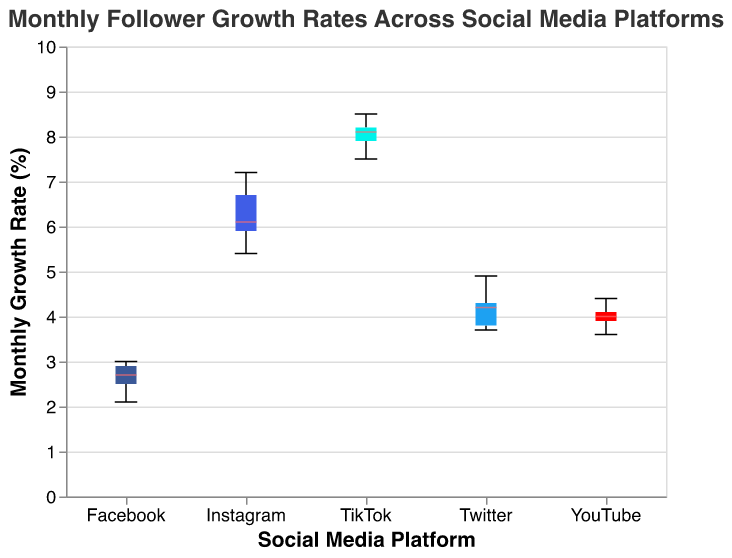How many social media platforms are compared in the plot? The x-axis displays the social media platforms. There are five distinct platforms visible: Instagram, Twitter, Facebook, TikTok, and YouTube.
Answer: 5 Which platform shows the highest median monthly follower growth rate? To find the highest median, look at where the median line is located within each box plot. TikTok has the highest median line, which is visually highest among the platforms.
Answer: TikTok Is the median growth rate for Facebook greater than that for Twitter? Analyze the position of the median lines within their respective boxes for Facebook and Twitter. The median for Facebook is lower than for Twitter.
Answer: No What is the spread of monthly growth rates on TikTok compared to Instagram? To compare the spread, look at the range from the minimum to the maximum values in the notched box plot. TikTok has a wider spread compared to Instagram.
Answer: TikTok has a wider spread Which platform has the narrowest interquartile range? The interquartile range (IQR) is the width of the box in the plot. Facebook has the narrowest interquartile range as its box is the smallest among all the platforms.
Answer: Facebook What is the difference in the median growth rates between Instagram and YouTube? Identify the median lines for Instagram and YouTube. The median for Instagram is around 6.1%, and for YouTube, it is around 4.0%. Subtract YouTube's median from Instagram's median: 6.1% - 4.0% = 2.1%.
Answer: 2.1% Are there any platforms with outliers, and if so, which ones? Outliers in a box plot are represented as points outside the whiskers. By visually inspecting, there are no outliers shown in the box plots for any of the platforms.
Answer: No Order the platforms by their median monthly growth rates from highest to lowest. Look at the median lines for each platform and compare their positions: TikTok > Instagram > YouTube > Twitter > Facebook.
Answer: TikTok, Instagram, YouTube, Twitter, Facebook 